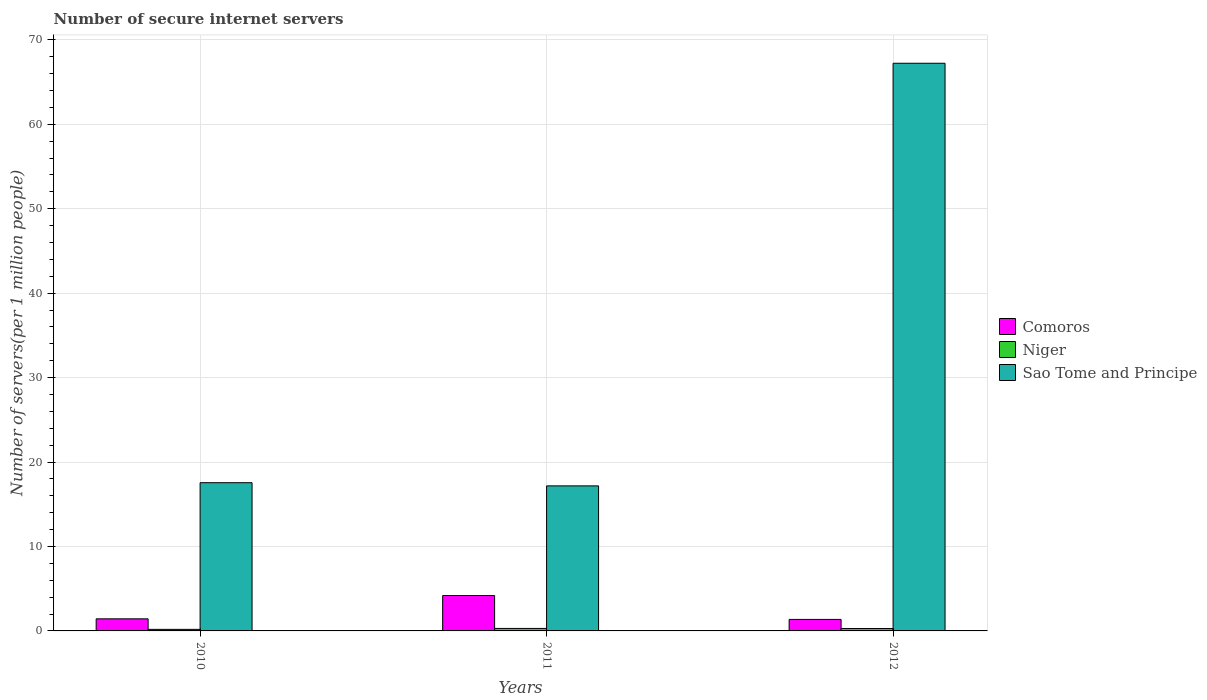How many different coloured bars are there?
Your answer should be compact. 3. How many bars are there on the 2nd tick from the left?
Provide a succinct answer. 3. How many bars are there on the 2nd tick from the right?
Ensure brevity in your answer.  3. What is the label of the 1st group of bars from the left?
Provide a short and direct response. 2010. In how many cases, is the number of bars for a given year not equal to the number of legend labels?
Offer a terse response. 0. What is the number of secure internet servers in Comoros in 2011?
Your answer should be very brief. 4.19. Across all years, what is the maximum number of secure internet servers in Sao Tome and Principe?
Your answer should be very brief. 67.23. Across all years, what is the minimum number of secure internet servers in Sao Tome and Principe?
Your response must be concise. 17.18. In which year was the number of secure internet servers in Comoros maximum?
Your answer should be very brief. 2011. In which year was the number of secure internet servers in Sao Tome and Principe minimum?
Offer a very short reply. 2011. What is the total number of secure internet servers in Sao Tome and Principe in the graph?
Your answer should be very brief. 101.97. What is the difference between the number of secure internet servers in Niger in 2010 and that in 2012?
Your response must be concise. -0.1. What is the difference between the number of secure internet servers in Niger in 2010 and the number of secure internet servers in Sao Tome and Principe in 2012?
Provide a succinct answer. -67.05. What is the average number of secure internet servers in Niger per year?
Your answer should be compact. 0.25. In the year 2011, what is the difference between the number of secure internet servers in Sao Tome and Principe and number of secure internet servers in Niger?
Provide a succinct answer. 16.88. What is the ratio of the number of secure internet servers in Niger in 2010 to that in 2012?
Provide a short and direct response. 0.65. Is the number of secure internet servers in Sao Tome and Principe in 2010 less than that in 2012?
Provide a succinct answer. Yes. Is the difference between the number of secure internet servers in Sao Tome and Principe in 2011 and 2012 greater than the difference between the number of secure internet servers in Niger in 2011 and 2012?
Provide a short and direct response. No. What is the difference between the highest and the second highest number of secure internet servers in Comoros?
Your response must be concise. 2.76. What is the difference between the highest and the lowest number of secure internet servers in Comoros?
Ensure brevity in your answer.  2.83. What does the 3rd bar from the left in 2010 represents?
Your response must be concise. Sao Tome and Principe. What does the 3rd bar from the right in 2012 represents?
Make the answer very short. Comoros. Is it the case that in every year, the sum of the number of secure internet servers in Comoros and number of secure internet servers in Sao Tome and Principe is greater than the number of secure internet servers in Niger?
Offer a terse response. Yes. How many bars are there?
Provide a succinct answer. 9. Are all the bars in the graph horizontal?
Your response must be concise. No. How many years are there in the graph?
Your answer should be compact. 3. What is the difference between two consecutive major ticks on the Y-axis?
Your answer should be very brief. 10. Are the values on the major ticks of Y-axis written in scientific E-notation?
Your answer should be compact. No. Does the graph contain grids?
Your answer should be very brief. Yes. Where does the legend appear in the graph?
Make the answer very short. Center right. How are the legend labels stacked?
Your answer should be compact. Vertical. What is the title of the graph?
Offer a terse response. Number of secure internet servers. What is the label or title of the Y-axis?
Make the answer very short. Number of servers(per 1 million people). What is the Number of servers(per 1 million people) in Comoros in 2010?
Your response must be concise. 1.43. What is the Number of servers(per 1 million people) in Niger in 2010?
Ensure brevity in your answer.  0.18. What is the Number of servers(per 1 million people) of Sao Tome and Principe in 2010?
Offer a terse response. 17.56. What is the Number of servers(per 1 million people) of Comoros in 2011?
Offer a terse response. 4.19. What is the Number of servers(per 1 million people) of Niger in 2011?
Offer a very short reply. 0.3. What is the Number of servers(per 1 million people) in Sao Tome and Principe in 2011?
Your answer should be compact. 17.18. What is the Number of servers(per 1 million people) of Comoros in 2012?
Your response must be concise. 1.36. What is the Number of servers(per 1 million people) of Niger in 2012?
Your response must be concise. 0.28. What is the Number of servers(per 1 million people) in Sao Tome and Principe in 2012?
Offer a very short reply. 67.23. Across all years, what is the maximum Number of servers(per 1 million people) of Comoros?
Your response must be concise. 4.19. Across all years, what is the maximum Number of servers(per 1 million people) of Niger?
Make the answer very short. 0.3. Across all years, what is the maximum Number of servers(per 1 million people) in Sao Tome and Principe?
Your response must be concise. 67.23. Across all years, what is the minimum Number of servers(per 1 million people) of Comoros?
Give a very brief answer. 1.36. Across all years, what is the minimum Number of servers(per 1 million people) in Niger?
Offer a terse response. 0.18. Across all years, what is the minimum Number of servers(per 1 million people) of Sao Tome and Principe?
Provide a short and direct response. 17.18. What is the total Number of servers(per 1 million people) in Comoros in the graph?
Provide a succinct answer. 6.98. What is the total Number of servers(per 1 million people) of Niger in the graph?
Keep it short and to the point. 0.76. What is the total Number of servers(per 1 million people) in Sao Tome and Principe in the graph?
Make the answer very short. 101.97. What is the difference between the Number of servers(per 1 million people) of Comoros in 2010 and that in 2011?
Provide a short and direct response. -2.76. What is the difference between the Number of servers(per 1 million people) in Niger in 2010 and that in 2011?
Ensure brevity in your answer.  -0.11. What is the difference between the Number of servers(per 1 million people) in Sao Tome and Principe in 2010 and that in 2011?
Your response must be concise. 0.38. What is the difference between the Number of servers(per 1 million people) in Comoros in 2010 and that in 2012?
Offer a terse response. 0.07. What is the difference between the Number of servers(per 1 million people) in Niger in 2010 and that in 2012?
Offer a terse response. -0.1. What is the difference between the Number of servers(per 1 million people) in Sao Tome and Principe in 2010 and that in 2012?
Give a very brief answer. -49.68. What is the difference between the Number of servers(per 1 million people) of Comoros in 2011 and that in 2012?
Give a very brief answer. 2.83. What is the difference between the Number of servers(per 1 million people) of Niger in 2011 and that in 2012?
Offer a terse response. 0.01. What is the difference between the Number of servers(per 1 million people) of Sao Tome and Principe in 2011 and that in 2012?
Offer a very short reply. -50.06. What is the difference between the Number of servers(per 1 million people) in Comoros in 2010 and the Number of servers(per 1 million people) in Niger in 2011?
Provide a short and direct response. 1.14. What is the difference between the Number of servers(per 1 million people) of Comoros in 2010 and the Number of servers(per 1 million people) of Sao Tome and Principe in 2011?
Make the answer very short. -15.75. What is the difference between the Number of servers(per 1 million people) in Niger in 2010 and the Number of servers(per 1 million people) in Sao Tome and Principe in 2011?
Make the answer very short. -16.99. What is the difference between the Number of servers(per 1 million people) in Comoros in 2010 and the Number of servers(per 1 million people) in Niger in 2012?
Your response must be concise. 1.15. What is the difference between the Number of servers(per 1 million people) in Comoros in 2010 and the Number of servers(per 1 million people) in Sao Tome and Principe in 2012?
Provide a short and direct response. -65.8. What is the difference between the Number of servers(per 1 million people) of Niger in 2010 and the Number of servers(per 1 million people) of Sao Tome and Principe in 2012?
Give a very brief answer. -67.05. What is the difference between the Number of servers(per 1 million people) in Comoros in 2011 and the Number of servers(per 1 million people) in Niger in 2012?
Offer a very short reply. 3.91. What is the difference between the Number of servers(per 1 million people) in Comoros in 2011 and the Number of servers(per 1 million people) in Sao Tome and Principe in 2012?
Your response must be concise. -63.04. What is the difference between the Number of servers(per 1 million people) in Niger in 2011 and the Number of servers(per 1 million people) in Sao Tome and Principe in 2012?
Your answer should be very brief. -66.94. What is the average Number of servers(per 1 million people) of Comoros per year?
Offer a very short reply. 2.33. What is the average Number of servers(per 1 million people) in Niger per year?
Provide a short and direct response. 0.25. What is the average Number of servers(per 1 million people) in Sao Tome and Principe per year?
Offer a terse response. 33.99. In the year 2010, what is the difference between the Number of servers(per 1 million people) of Comoros and Number of servers(per 1 million people) of Niger?
Offer a very short reply. 1.25. In the year 2010, what is the difference between the Number of servers(per 1 million people) of Comoros and Number of servers(per 1 million people) of Sao Tome and Principe?
Make the answer very short. -16.12. In the year 2010, what is the difference between the Number of servers(per 1 million people) in Niger and Number of servers(per 1 million people) in Sao Tome and Principe?
Your answer should be compact. -17.37. In the year 2011, what is the difference between the Number of servers(per 1 million people) in Comoros and Number of servers(per 1 million people) in Niger?
Ensure brevity in your answer.  3.9. In the year 2011, what is the difference between the Number of servers(per 1 million people) of Comoros and Number of servers(per 1 million people) of Sao Tome and Principe?
Your response must be concise. -12.99. In the year 2011, what is the difference between the Number of servers(per 1 million people) in Niger and Number of servers(per 1 million people) in Sao Tome and Principe?
Make the answer very short. -16.88. In the year 2012, what is the difference between the Number of servers(per 1 million people) in Comoros and Number of servers(per 1 million people) in Niger?
Offer a terse response. 1.08. In the year 2012, what is the difference between the Number of servers(per 1 million people) of Comoros and Number of servers(per 1 million people) of Sao Tome and Principe?
Offer a terse response. -65.87. In the year 2012, what is the difference between the Number of servers(per 1 million people) in Niger and Number of servers(per 1 million people) in Sao Tome and Principe?
Offer a terse response. -66.95. What is the ratio of the Number of servers(per 1 million people) of Comoros in 2010 to that in 2011?
Keep it short and to the point. 0.34. What is the ratio of the Number of servers(per 1 million people) of Niger in 2010 to that in 2011?
Your response must be concise. 0.62. What is the ratio of the Number of servers(per 1 million people) of Comoros in 2010 to that in 2012?
Offer a very short reply. 1.05. What is the ratio of the Number of servers(per 1 million people) in Niger in 2010 to that in 2012?
Your answer should be very brief. 0.65. What is the ratio of the Number of servers(per 1 million people) in Sao Tome and Principe in 2010 to that in 2012?
Your answer should be compact. 0.26. What is the ratio of the Number of servers(per 1 million people) in Comoros in 2011 to that in 2012?
Provide a succinct answer. 3.07. What is the ratio of the Number of servers(per 1 million people) in Niger in 2011 to that in 2012?
Offer a very short reply. 1.04. What is the ratio of the Number of servers(per 1 million people) in Sao Tome and Principe in 2011 to that in 2012?
Give a very brief answer. 0.26. What is the difference between the highest and the second highest Number of servers(per 1 million people) of Comoros?
Offer a terse response. 2.76. What is the difference between the highest and the second highest Number of servers(per 1 million people) in Niger?
Ensure brevity in your answer.  0.01. What is the difference between the highest and the second highest Number of servers(per 1 million people) of Sao Tome and Principe?
Ensure brevity in your answer.  49.68. What is the difference between the highest and the lowest Number of servers(per 1 million people) in Comoros?
Your response must be concise. 2.83. What is the difference between the highest and the lowest Number of servers(per 1 million people) in Niger?
Keep it short and to the point. 0.11. What is the difference between the highest and the lowest Number of servers(per 1 million people) in Sao Tome and Principe?
Your response must be concise. 50.06. 